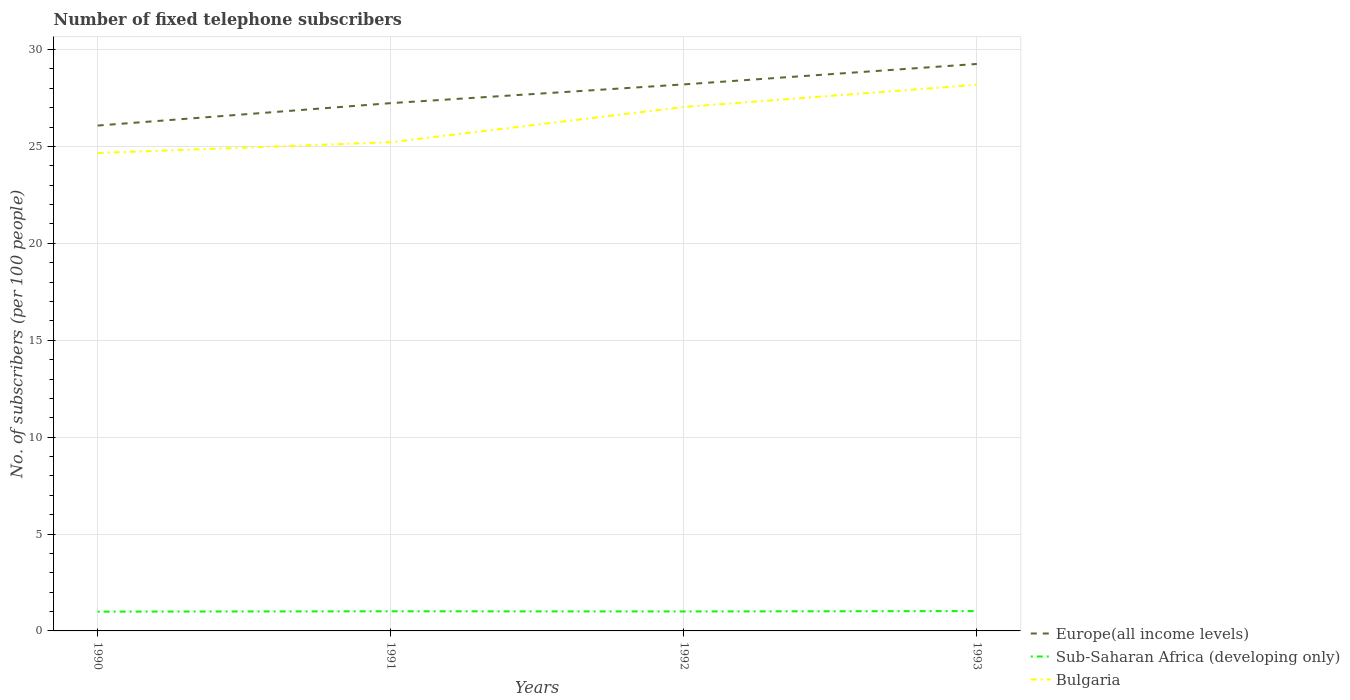How many different coloured lines are there?
Your answer should be very brief. 3. Is the number of lines equal to the number of legend labels?
Your response must be concise. Yes. Across all years, what is the maximum number of fixed telephone subscribers in Sub-Saharan Africa (developing only)?
Give a very brief answer. 1. In which year was the number of fixed telephone subscribers in Europe(all income levels) maximum?
Offer a very short reply. 1990. What is the total number of fixed telephone subscribers in Bulgaria in the graph?
Your answer should be compact. -2.38. What is the difference between the highest and the second highest number of fixed telephone subscribers in Bulgaria?
Provide a succinct answer. 3.52. Is the number of fixed telephone subscribers in Sub-Saharan Africa (developing only) strictly greater than the number of fixed telephone subscribers in Bulgaria over the years?
Offer a terse response. Yes. How many years are there in the graph?
Your response must be concise. 4. What is the difference between two consecutive major ticks on the Y-axis?
Your answer should be compact. 5. Are the values on the major ticks of Y-axis written in scientific E-notation?
Make the answer very short. No. What is the title of the graph?
Your response must be concise. Number of fixed telephone subscribers. Does "Romania" appear as one of the legend labels in the graph?
Your answer should be very brief. No. What is the label or title of the Y-axis?
Provide a short and direct response. No. of subscribers (per 100 people). What is the No. of subscribers (per 100 people) in Europe(all income levels) in 1990?
Provide a succinct answer. 26.08. What is the No. of subscribers (per 100 people) of Sub-Saharan Africa (developing only) in 1990?
Give a very brief answer. 1. What is the No. of subscribers (per 100 people) in Bulgaria in 1990?
Your answer should be very brief. 24.66. What is the No. of subscribers (per 100 people) of Europe(all income levels) in 1991?
Ensure brevity in your answer.  27.24. What is the No. of subscribers (per 100 people) of Sub-Saharan Africa (developing only) in 1991?
Keep it short and to the point. 1.01. What is the No. of subscribers (per 100 people) in Bulgaria in 1991?
Make the answer very short. 25.22. What is the No. of subscribers (per 100 people) of Europe(all income levels) in 1992?
Give a very brief answer. 28.2. What is the No. of subscribers (per 100 people) in Sub-Saharan Africa (developing only) in 1992?
Ensure brevity in your answer.  1. What is the No. of subscribers (per 100 people) in Bulgaria in 1992?
Make the answer very short. 27.04. What is the No. of subscribers (per 100 people) of Europe(all income levels) in 1993?
Your answer should be compact. 29.26. What is the No. of subscribers (per 100 people) of Sub-Saharan Africa (developing only) in 1993?
Provide a succinct answer. 1.02. What is the No. of subscribers (per 100 people) in Bulgaria in 1993?
Give a very brief answer. 28.18. Across all years, what is the maximum No. of subscribers (per 100 people) in Europe(all income levels)?
Offer a terse response. 29.26. Across all years, what is the maximum No. of subscribers (per 100 people) of Sub-Saharan Africa (developing only)?
Your response must be concise. 1.02. Across all years, what is the maximum No. of subscribers (per 100 people) of Bulgaria?
Your answer should be compact. 28.18. Across all years, what is the minimum No. of subscribers (per 100 people) of Europe(all income levels)?
Offer a very short reply. 26.08. Across all years, what is the minimum No. of subscribers (per 100 people) in Sub-Saharan Africa (developing only)?
Your answer should be compact. 1. Across all years, what is the minimum No. of subscribers (per 100 people) in Bulgaria?
Ensure brevity in your answer.  24.66. What is the total No. of subscribers (per 100 people) in Europe(all income levels) in the graph?
Your answer should be very brief. 110.78. What is the total No. of subscribers (per 100 people) in Sub-Saharan Africa (developing only) in the graph?
Offer a terse response. 4.04. What is the total No. of subscribers (per 100 people) in Bulgaria in the graph?
Your answer should be very brief. 105.1. What is the difference between the No. of subscribers (per 100 people) in Europe(all income levels) in 1990 and that in 1991?
Your answer should be compact. -1.16. What is the difference between the No. of subscribers (per 100 people) in Sub-Saharan Africa (developing only) in 1990 and that in 1991?
Your answer should be compact. -0.02. What is the difference between the No. of subscribers (per 100 people) of Bulgaria in 1990 and that in 1991?
Offer a very short reply. -0.56. What is the difference between the No. of subscribers (per 100 people) in Europe(all income levels) in 1990 and that in 1992?
Keep it short and to the point. -2.12. What is the difference between the No. of subscribers (per 100 people) of Sub-Saharan Africa (developing only) in 1990 and that in 1992?
Offer a terse response. -0.01. What is the difference between the No. of subscribers (per 100 people) in Bulgaria in 1990 and that in 1992?
Provide a short and direct response. -2.38. What is the difference between the No. of subscribers (per 100 people) in Europe(all income levels) in 1990 and that in 1993?
Your answer should be compact. -3.18. What is the difference between the No. of subscribers (per 100 people) of Sub-Saharan Africa (developing only) in 1990 and that in 1993?
Keep it short and to the point. -0.03. What is the difference between the No. of subscribers (per 100 people) of Bulgaria in 1990 and that in 1993?
Your response must be concise. -3.52. What is the difference between the No. of subscribers (per 100 people) in Europe(all income levels) in 1991 and that in 1992?
Your response must be concise. -0.97. What is the difference between the No. of subscribers (per 100 people) in Sub-Saharan Africa (developing only) in 1991 and that in 1992?
Your answer should be compact. 0.01. What is the difference between the No. of subscribers (per 100 people) in Bulgaria in 1991 and that in 1992?
Make the answer very short. -1.82. What is the difference between the No. of subscribers (per 100 people) of Europe(all income levels) in 1991 and that in 1993?
Your answer should be very brief. -2.02. What is the difference between the No. of subscribers (per 100 people) in Sub-Saharan Africa (developing only) in 1991 and that in 1993?
Make the answer very short. -0.01. What is the difference between the No. of subscribers (per 100 people) of Bulgaria in 1991 and that in 1993?
Your answer should be compact. -2.97. What is the difference between the No. of subscribers (per 100 people) in Europe(all income levels) in 1992 and that in 1993?
Keep it short and to the point. -1.05. What is the difference between the No. of subscribers (per 100 people) in Sub-Saharan Africa (developing only) in 1992 and that in 1993?
Your answer should be compact. -0.02. What is the difference between the No. of subscribers (per 100 people) of Bulgaria in 1992 and that in 1993?
Keep it short and to the point. -1.15. What is the difference between the No. of subscribers (per 100 people) of Europe(all income levels) in 1990 and the No. of subscribers (per 100 people) of Sub-Saharan Africa (developing only) in 1991?
Your response must be concise. 25.07. What is the difference between the No. of subscribers (per 100 people) in Europe(all income levels) in 1990 and the No. of subscribers (per 100 people) in Bulgaria in 1991?
Provide a succinct answer. 0.86. What is the difference between the No. of subscribers (per 100 people) in Sub-Saharan Africa (developing only) in 1990 and the No. of subscribers (per 100 people) in Bulgaria in 1991?
Give a very brief answer. -24.22. What is the difference between the No. of subscribers (per 100 people) of Europe(all income levels) in 1990 and the No. of subscribers (per 100 people) of Sub-Saharan Africa (developing only) in 1992?
Give a very brief answer. 25.07. What is the difference between the No. of subscribers (per 100 people) of Europe(all income levels) in 1990 and the No. of subscribers (per 100 people) of Bulgaria in 1992?
Offer a very short reply. -0.96. What is the difference between the No. of subscribers (per 100 people) in Sub-Saharan Africa (developing only) in 1990 and the No. of subscribers (per 100 people) in Bulgaria in 1992?
Keep it short and to the point. -26.04. What is the difference between the No. of subscribers (per 100 people) of Europe(all income levels) in 1990 and the No. of subscribers (per 100 people) of Sub-Saharan Africa (developing only) in 1993?
Provide a short and direct response. 25.06. What is the difference between the No. of subscribers (per 100 people) in Europe(all income levels) in 1990 and the No. of subscribers (per 100 people) in Bulgaria in 1993?
Provide a short and direct response. -2.1. What is the difference between the No. of subscribers (per 100 people) of Sub-Saharan Africa (developing only) in 1990 and the No. of subscribers (per 100 people) of Bulgaria in 1993?
Offer a terse response. -27.19. What is the difference between the No. of subscribers (per 100 people) of Europe(all income levels) in 1991 and the No. of subscribers (per 100 people) of Sub-Saharan Africa (developing only) in 1992?
Keep it short and to the point. 26.23. What is the difference between the No. of subscribers (per 100 people) of Europe(all income levels) in 1991 and the No. of subscribers (per 100 people) of Bulgaria in 1992?
Ensure brevity in your answer.  0.2. What is the difference between the No. of subscribers (per 100 people) in Sub-Saharan Africa (developing only) in 1991 and the No. of subscribers (per 100 people) in Bulgaria in 1992?
Offer a very short reply. -26.02. What is the difference between the No. of subscribers (per 100 people) of Europe(all income levels) in 1991 and the No. of subscribers (per 100 people) of Sub-Saharan Africa (developing only) in 1993?
Provide a succinct answer. 26.21. What is the difference between the No. of subscribers (per 100 people) of Europe(all income levels) in 1991 and the No. of subscribers (per 100 people) of Bulgaria in 1993?
Make the answer very short. -0.95. What is the difference between the No. of subscribers (per 100 people) of Sub-Saharan Africa (developing only) in 1991 and the No. of subscribers (per 100 people) of Bulgaria in 1993?
Give a very brief answer. -27.17. What is the difference between the No. of subscribers (per 100 people) in Europe(all income levels) in 1992 and the No. of subscribers (per 100 people) in Sub-Saharan Africa (developing only) in 1993?
Your answer should be compact. 27.18. What is the difference between the No. of subscribers (per 100 people) of Europe(all income levels) in 1992 and the No. of subscribers (per 100 people) of Bulgaria in 1993?
Your response must be concise. 0.02. What is the difference between the No. of subscribers (per 100 people) of Sub-Saharan Africa (developing only) in 1992 and the No. of subscribers (per 100 people) of Bulgaria in 1993?
Provide a short and direct response. -27.18. What is the average No. of subscribers (per 100 people) in Europe(all income levels) per year?
Keep it short and to the point. 27.69. What is the average No. of subscribers (per 100 people) in Sub-Saharan Africa (developing only) per year?
Your answer should be very brief. 1.01. What is the average No. of subscribers (per 100 people) in Bulgaria per year?
Offer a terse response. 26.28. In the year 1990, what is the difference between the No. of subscribers (per 100 people) of Europe(all income levels) and No. of subscribers (per 100 people) of Sub-Saharan Africa (developing only)?
Provide a short and direct response. 25.08. In the year 1990, what is the difference between the No. of subscribers (per 100 people) of Europe(all income levels) and No. of subscribers (per 100 people) of Bulgaria?
Your response must be concise. 1.42. In the year 1990, what is the difference between the No. of subscribers (per 100 people) in Sub-Saharan Africa (developing only) and No. of subscribers (per 100 people) in Bulgaria?
Offer a terse response. -23.67. In the year 1991, what is the difference between the No. of subscribers (per 100 people) in Europe(all income levels) and No. of subscribers (per 100 people) in Sub-Saharan Africa (developing only)?
Provide a short and direct response. 26.22. In the year 1991, what is the difference between the No. of subscribers (per 100 people) of Europe(all income levels) and No. of subscribers (per 100 people) of Bulgaria?
Give a very brief answer. 2.02. In the year 1991, what is the difference between the No. of subscribers (per 100 people) in Sub-Saharan Africa (developing only) and No. of subscribers (per 100 people) in Bulgaria?
Provide a succinct answer. -24.21. In the year 1992, what is the difference between the No. of subscribers (per 100 people) in Europe(all income levels) and No. of subscribers (per 100 people) in Sub-Saharan Africa (developing only)?
Your response must be concise. 27.2. In the year 1992, what is the difference between the No. of subscribers (per 100 people) in Europe(all income levels) and No. of subscribers (per 100 people) in Bulgaria?
Provide a short and direct response. 1.17. In the year 1992, what is the difference between the No. of subscribers (per 100 people) of Sub-Saharan Africa (developing only) and No. of subscribers (per 100 people) of Bulgaria?
Offer a very short reply. -26.03. In the year 1993, what is the difference between the No. of subscribers (per 100 people) of Europe(all income levels) and No. of subscribers (per 100 people) of Sub-Saharan Africa (developing only)?
Provide a succinct answer. 28.23. In the year 1993, what is the difference between the No. of subscribers (per 100 people) in Europe(all income levels) and No. of subscribers (per 100 people) in Bulgaria?
Offer a terse response. 1.07. In the year 1993, what is the difference between the No. of subscribers (per 100 people) of Sub-Saharan Africa (developing only) and No. of subscribers (per 100 people) of Bulgaria?
Provide a short and direct response. -27.16. What is the ratio of the No. of subscribers (per 100 people) of Europe(all income levels) in 1990 to that in 1991?
Give a very brief answer. 0.96. What is the ratio of the No. of subscribers (per 100 people) in Sub-Saharan Africa (developing only) in 1990 to that in 1991?
Keep it short and to the point. 0.98. What is the ratio of the No. of subscribers (per 100 people) in Bulgaria in 1990 to that in 1991?
Offer a terse response. 0.98. What is the ratio of the No. of subscribers (per 100 people) in Europe(all income levels) in 1990 to that in 1992?
Give a very brief answer. 0.92. What is the ratio of the No. of subscribers (per 100 people) of Bulgaria in 1990 to that in 1992?
Give a very brief answer. 0.91. What is the ratio of the No. of subscribers (per 100 people) in Europe(all income levels) in 1990 to that in 1993?
Offer a very short reply. 0.89. What is the ratio of the No. of subscribers (per 100 people) in Sub-Saharan Africa (developing only) in 1990 to that in 1993?
Offer a very short reply. 0.97. What is the ratio of the No. of subscribers (per 100 people) of Bulgaria in 1990 to that in 1993?
Make the answer very short. 0.88. What is the ratio of the No. of subscribers (per 100 people) of Europe(all income levels) in 1991 to that in 1992?
Make the answer very short. 0.97. What is the ratio of the No. of subscribers (per 100 people) in Sub-Saharan Africa (developing only) in 1991 to that in 1992?
Make the answer very short. 1.01. What is the ratio of the No. of subscribers (per 100 people) of Bulgaria in 1991 to that in 1992?
Offer a terse response. 0.93. What is the ratio of the No. of subscribers (per 100 people) of Europe(all income levels) in 1991 to that in 1993?
Ensure brevity in your answer.  0.93. What is the ratio of the No. of subscribers (per 100 people) of Sub-Saharan Africa (developing only) in 1991 to that in 1993?
Your answer should be very brief. 0.99. What is the ratio of the No. of subscribers (per 100 people) in Bulgaria in 1991 to that in 1993?
Your answer should be compact. 0.89. What is the ratio of the No. of subscribers (per 100 people) of Europe(all income levels) in 1992 to that in 1993?
Offer a very short reply. 0.96. What is the ratio of the No. of subscribers (per 100 people) in Sub-Saharan Africa (developing only) in 1992 to that in 1993?
Offer a very short reply. 0.98. What is the ratio of the No. of subscribers (per 100 people) of Bulgaria in 1992 to that in 1993?
Provide a succinct answer. 0.96. What is the difference between the highest and the second highest No. of subscribers (per 100 people) in Europe(all income levels)?
Provide a short and direct response. 1.05. What is the difference between the highest and the second highest No. of subscribers (per 100 people) of Sub-Saharan Africa (developing only)?
Give a very brief answer. 0.01. What is the difference between the highest and the second highest No. of subscribers (per 100 people) in Bulgaria?
Your response must be concise. 1.15. What is the difference between the highest and the lowest No. of subscribers (per 100 people) in Europe(all income levels)?
Ensure brevity in your answer.  3.18. What is the difference between the highest and the lowest No. of subscribers (per 100 people) in Sub-Saharan Africa (developing only)?
Your answer should be very brief. 0.03. What is the difference between the highest and the lowest No. of subscribers (per 100 people) of Bulgaria?
Your answer should be very brief. 3.52. 